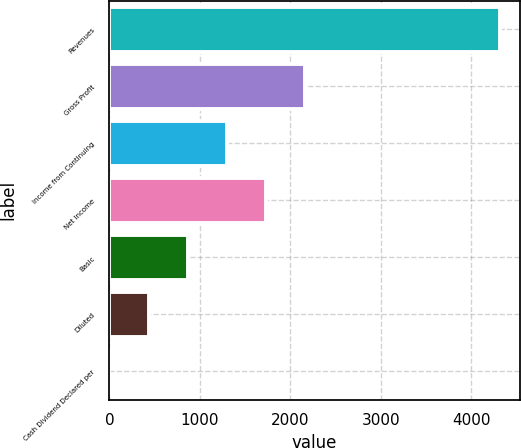Convert chart. <chart><loc_0><loc_0><loc_500><loc_500><bar_chart><fcel>Revenues<fcel>Gross Profit<fcel>Income from Continuing<fcel>Net Income<fcel>Basic<fcel>Diluted<fcel>Cash Dividend Declared per<nl><fcel>4321.9<fcel>2161.03<fcel>1296.67<fcel>1728.85<fcel>864.5<fcel>432.32<fcel>0.15<nl></chart> 